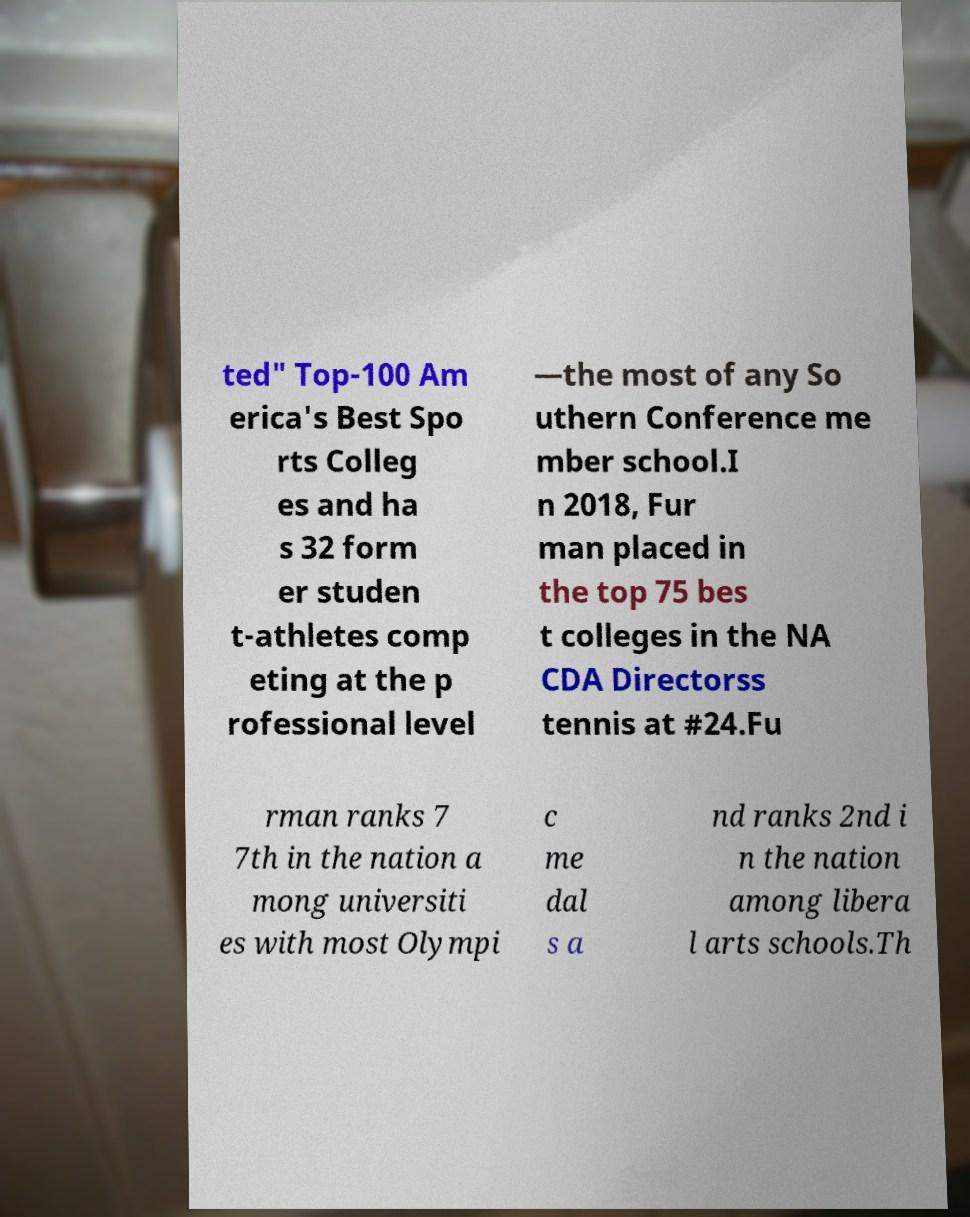For documentation purposes, I need the text within this image transcribed. Could you provide that? ted" Top-100 Am erica's Best Spo rts Colleg es and ha s 32 form er studen t-athletes comp eting at the p rofessional level —the most of any So uthern Conference me mber school.I n 2018, Fur man placed in the top 75 bes t colleges in the NA CDA Directorss tennis at #24.Fu rman ranks 7 7th in the nation a mong universiti es with most Olympi c me dal s a nd ranks 2nd i n the nation among libera l arts schools.Th 